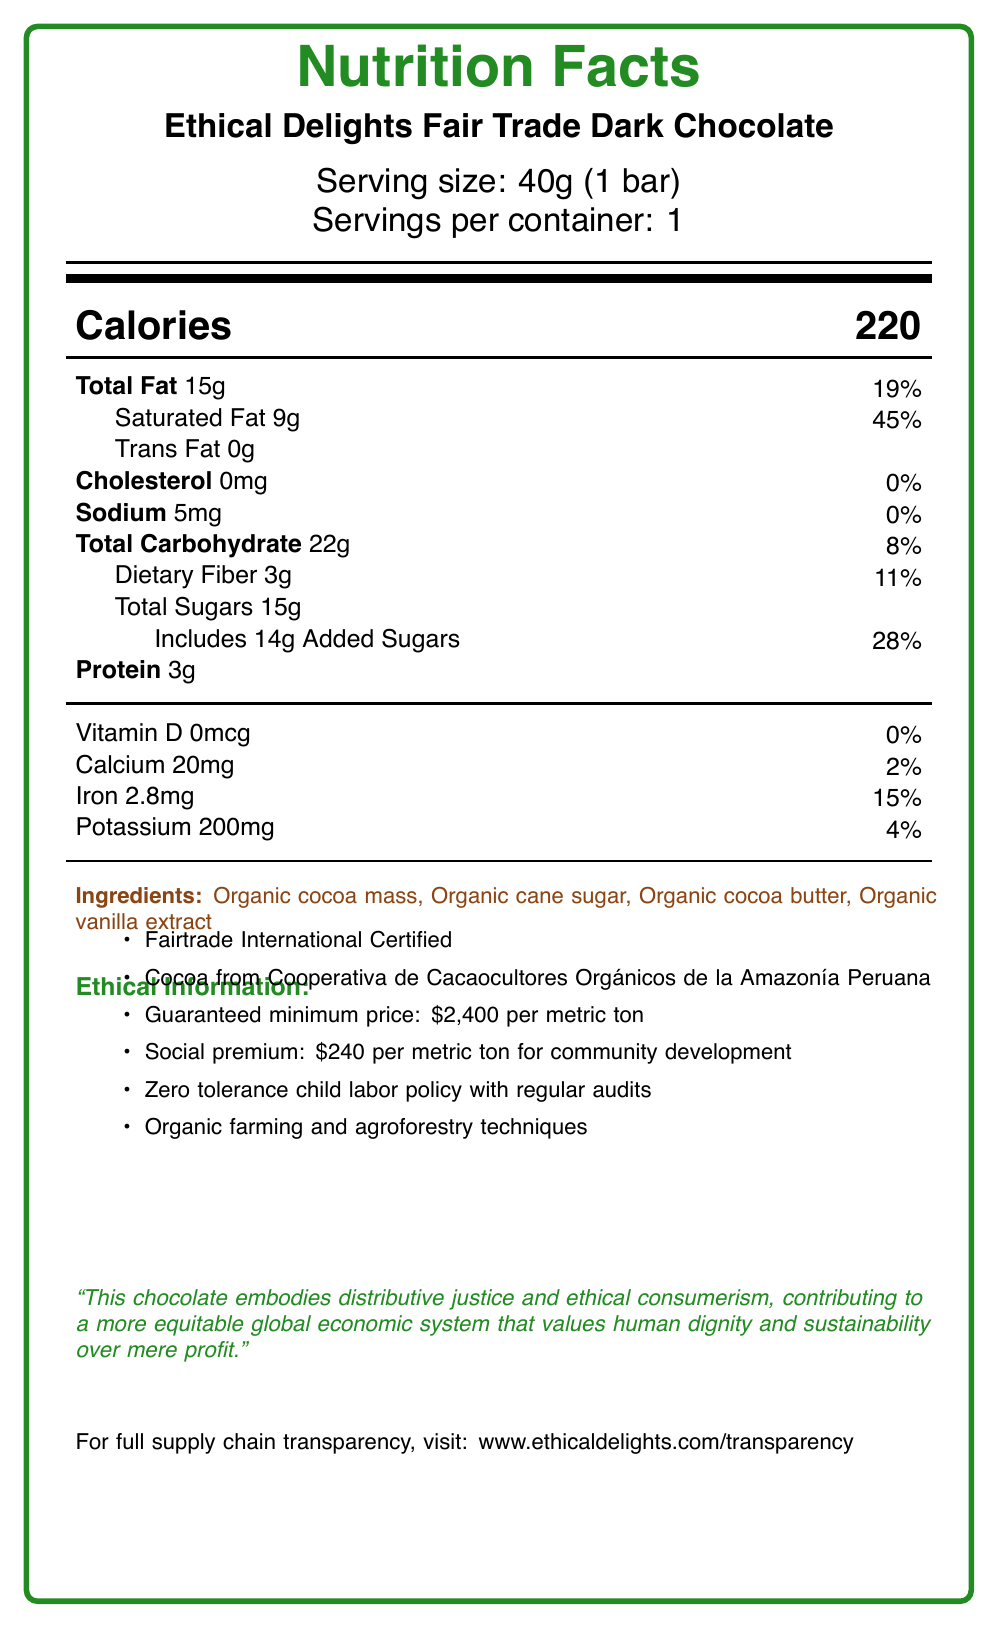what is the serving size of the chocolate bar? The document states that the serving size is 40g (1 bar).
Answer: 40g (1 bar) how much calcium does one serving of the chocolate bar provide? The document states that one serving provides 20mg of calcium.
Answer: 20mg what percentage of the daily value is the protein content in the chocolate bar? The document specifies that the chocolate bar has 3g of protein, but it does not provide the daily value percentage for protein.
Answer: The daily value percentage for protein is not listed. which ingredient is mentioned first among the ingredients list? The document lists organic cocoa mass first among the ingredients.
Answer: Organic cocoa mass from which cooperative is the cocoa sourced? The document states that the cocoa is sourced from the Cooperativa de Cacaocultores Orgánicos de la Amazonía Peruana.
Answer: Cooperativa de Cacaocultores Orgánicos de la Amazonía Peruana what is the guaranteed minimum price for the cocoa per metric ton? The document states that the guaranteed minimum price is $2,400 per metric ton.
Answer: $2,400 per metric ton what is the amount of added sugars in the chocolate bar? The document lists 14g of added sugars in the chocolate bar.
Answer: 14g how much potassium does the chocolate bar contain? A. 20mg B. 200mg C. 2.8mg D. 5mg The document states that the chocolate bar contains 200mg of potassium.
Answer: B what certification does the chocolate bar have? The document states that the chocolate bar is Fairtrade International Certified.
Answer: Fairtrade International what practices are employed in the farming of cocoa for this chocolate bar? A. Conventional farming B. Industrial farming C. Organic farming and agroforestry techniques The document specifies that organic farming and agroforestry techniques are used.
Answer: C is child labor tolerated in the production of this chocolate bar? The document states that there is a zero tolerance policy for child labor.
Answer: No summarize the ethical stance and economic impact of the chocolate bar as described in the document. The document emphasizes the principles of fairness and ethical consumerism, ensuring that the labor practices and sourcing of the cocoa are just and sustainable. The economic impact is positive, with fair trade premiums funding community development projects. Transparency is highlighted, with details available on their website.
Answer: The document describes the chocolate bar as promoting distributive justice and ethical consumerism. The chocolate bar contributes to a more equitable global economic system by ensuring fair labor practices, offering a guaranteed minimum price for cocoa, providing a social premium for community development, and employing organic and sustainable farming methods. Additionally, fair trade premiums have been used to fund education programs and healthcare facilities in cocoa-growing communities. The brand maintains full supply chain transparency. what is the bar code of the chocolate bar? The document does not provide any information related to a bar code.
Answer: Cannot be determined 